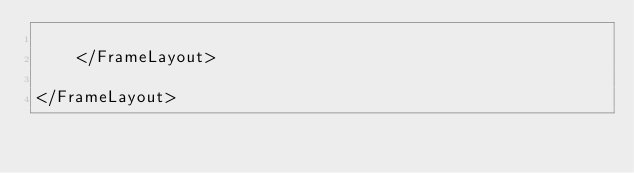Convert code to text. <code><loc_0><loc_0><loc_500><loc_500><_XML_>
    </FrameLayout>

</FrameLayout></code> 